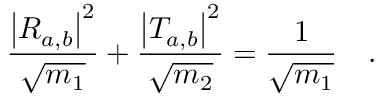Convert formula to latex. <formula><loc_0><loc_0><loc_500><loc_500>\frac { { \left | R _ { a , b } \right | } ^ { 2 } } { \sqrt { m _ { 1 } } } + \frac { { \left | T _ { a , b } \right | } ^ { 2 } } { \sqrt { m _ { 2 } } } = \frac { 1 } { \sqrt { m _ { 1 } } } \quad .</formula> 